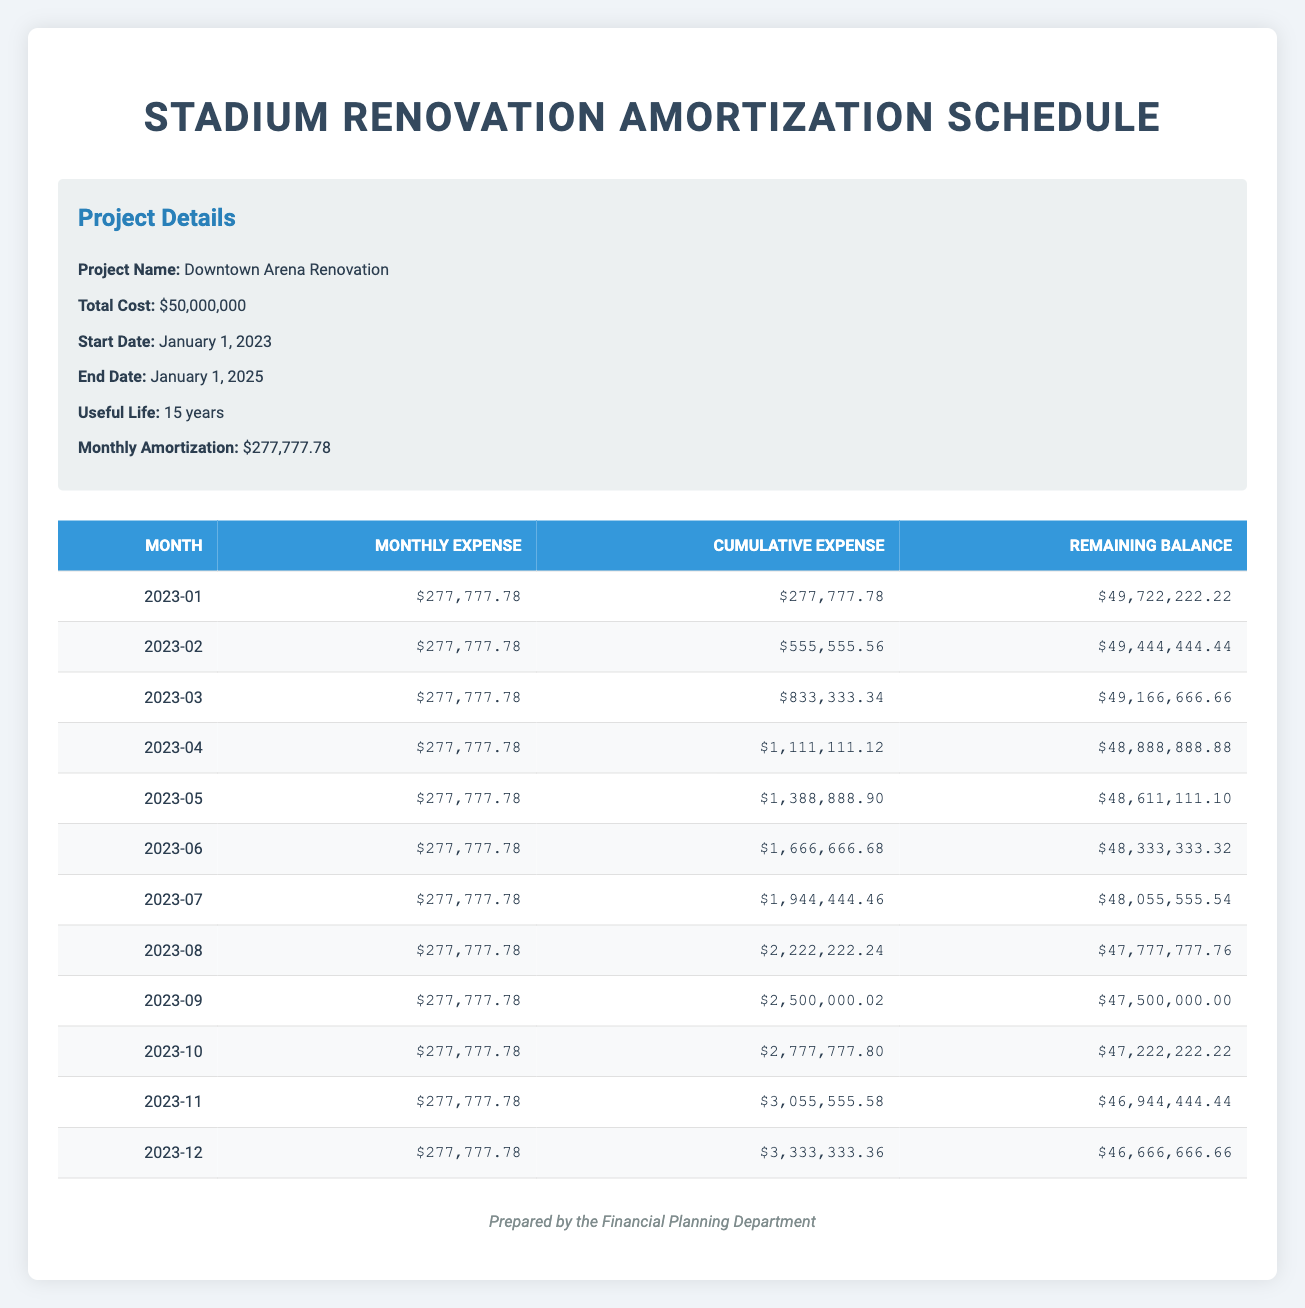What is the monthly expense for the stadium renovation? The monthly expense is explicitly listed in the "Monthly Expense" column for each month. For example, it shows $277,777.78 for all months listed.
Answer: 277777.78 What is the cumulative expense by December 2023? By looking at the "Cumulative Expense" column for December 2023, the total cumulative expense is $3,333,333.36.
Answer: 3333333.36 Is the remaining balance after six months more than 48 million? The remaining balance after June 2023 is $48,333,333.32, which is more than 48 million.
Answer: Yes What is the total cumulative expense for the first three months? The cumulative expenses for January, February, and March are $277,777.78, $555,555.56, and $833,333.34, respectively. Adding these gives a total of $1,666,666.68.
Answer: 1666666.68 How much is the remaining balance after twelve months? The remaining balance after twelve months is shown in the December 2023 row, which is $46,666,666.66.
Answer: 46666666.66 What is the total amortization over the first year? The monthly amortization is $277,777.78, and with 12 months in a year, the total amortization over the first year is $277,777.78 * 12 = $3,333,333.36.
Answer: 3333333.36 Has the cumulative expense exceeded $3 million by November 2023? The cumulative expense in November 2023 is $3,055,555.58, which indeed exceeds $3 million.
Answer: Yes What is the change in the remaining balance from January to December 2023? The remaining balance in January is $49,722,222.22 and in December is $46,666,666.66. The change is $49,722,222.22 - $46,666,666.66 = $3,055,555.56.
Answer: 3055555.56 How many months did it take to reach a cumulative expense of $2 million? Looking at the cumulative expenses, it exceeds $2 million after the 8th month (August) when the cumulative expense reaches $2,222,222.24. Therefore, it took 8 months.
Answer: 8 